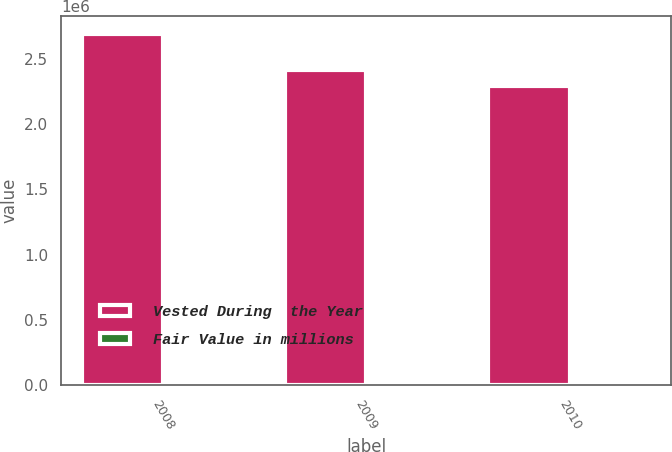Convert chart. <chart><loc_0><loc_0><loc_500><loc_500><stacked_bar_chart><ecel><fcel>2008<fcel>2009<fcel>2010<nl><fcel>Vested During  the Year<fcel>2.6946e+06<fcel>2.41482e+06<fcel>2.29621e+06<nl><fcel>Fair Value in millions<fcel>64<fcel>64<fcel>63<nl></chart> 